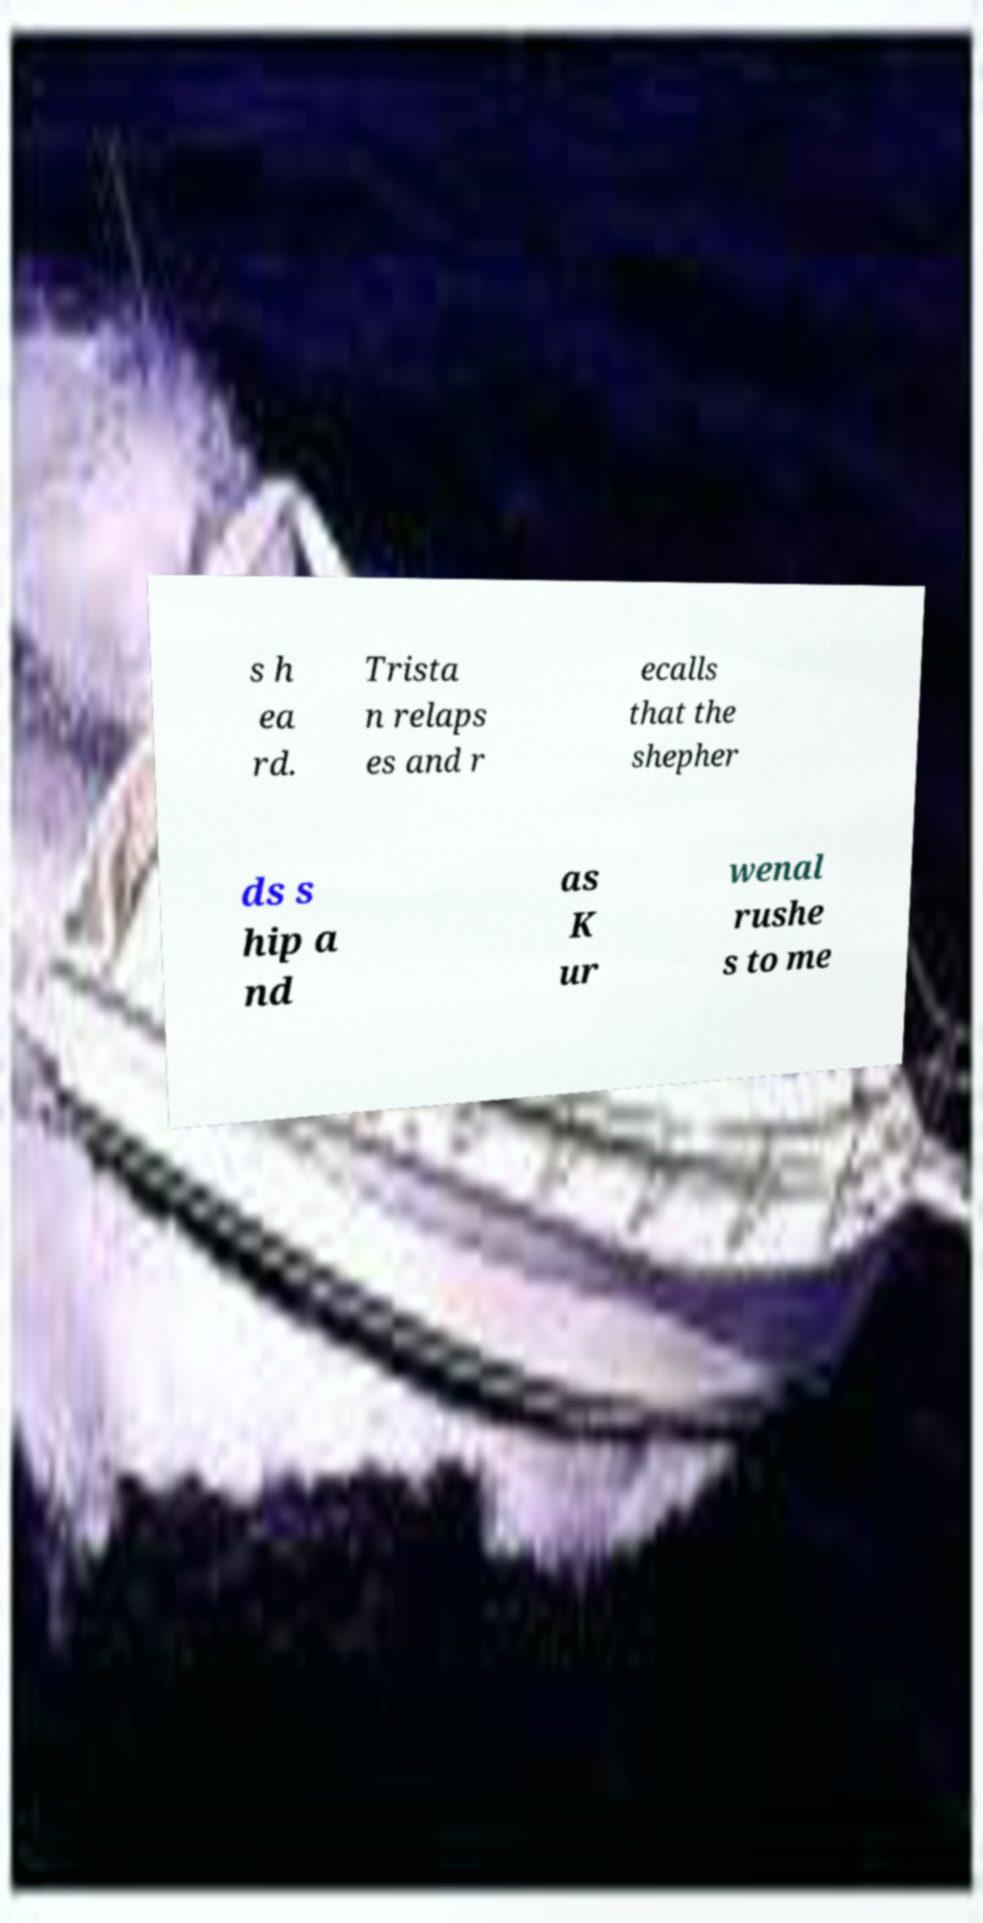Please read and relay the text visible in this image. What does it say? s h ea rd. Trista n relaps es and r ecalls that the shepher ds s hip a nd as K ur wenal rushe s to me 